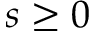<formula> <loc_0><loc_0><loc_500><loc_500>s \geq 0</formula> 